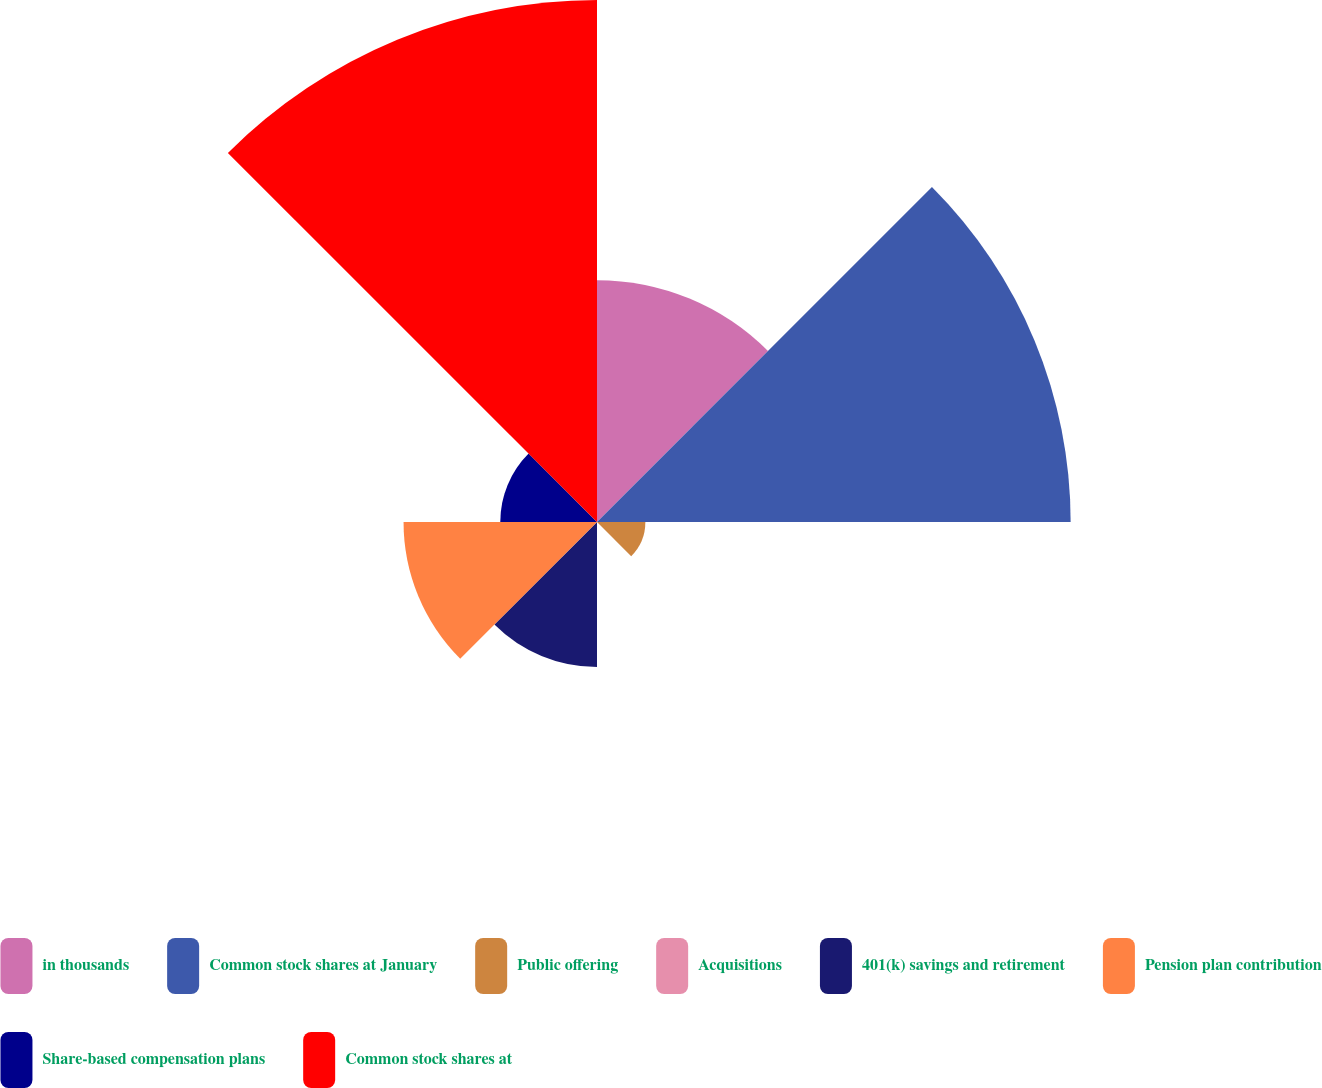Convert chart. <chart><loc_0><loc_0><loc_500><loc_500><pie_chart><fcel>in thousands<fcel>Common stock shares at January<fcel>Public offering<fcel>Acquisitions<fcel>401(k) savings and retirement<fcel>Pension plan contribution<fcel>Share-based compensation plans<fcel>Common stock shares at<nl><fcel>14.05%<fcel>27.52%<fcel>2.81%<fcel>0.0%<fcel>8.43%<fcel>11.24%<fcel>5.62%<fcel>30.33%<nl></chart> 